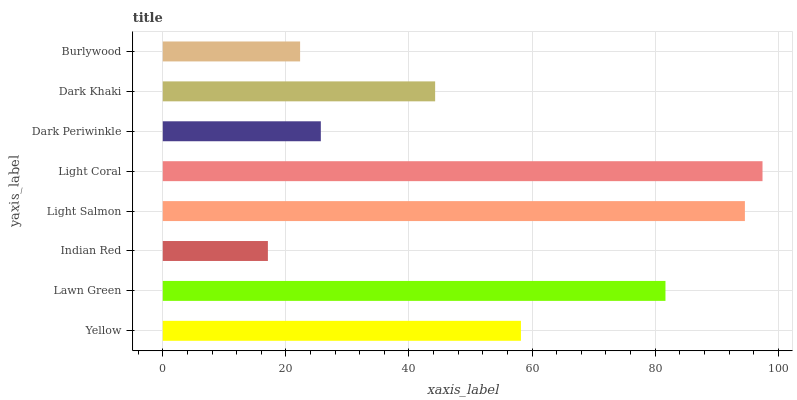Is Indian Red the minimum?
Answer yes or no. Yes. Is Light Coral the maximum?
Answer yes or no. Yes. Is Lawn Green the minimum?
Answer yes or no. No. Is Lawn Green the maximum?
Answer yes or no. No. Is Lawn Green greater than Yellow?
Answer yes or no. Yes. Is Yellow less than Lawn Green?
Answer yes or no. Yes. Is Yellow greater than Lawn Green?
Answer yes or no. No. Is Lawn Green less than Yellow?
Answer yes or no. No. Is Yellow the high median?
Answer yes or no. Yes. Is Dark Khaki the low median?
Answer yes or no. Yes. Is Light Coral the high median?
Answer yes or no. No. Is Lawn Green the low median?
Answer yes or no. No. 